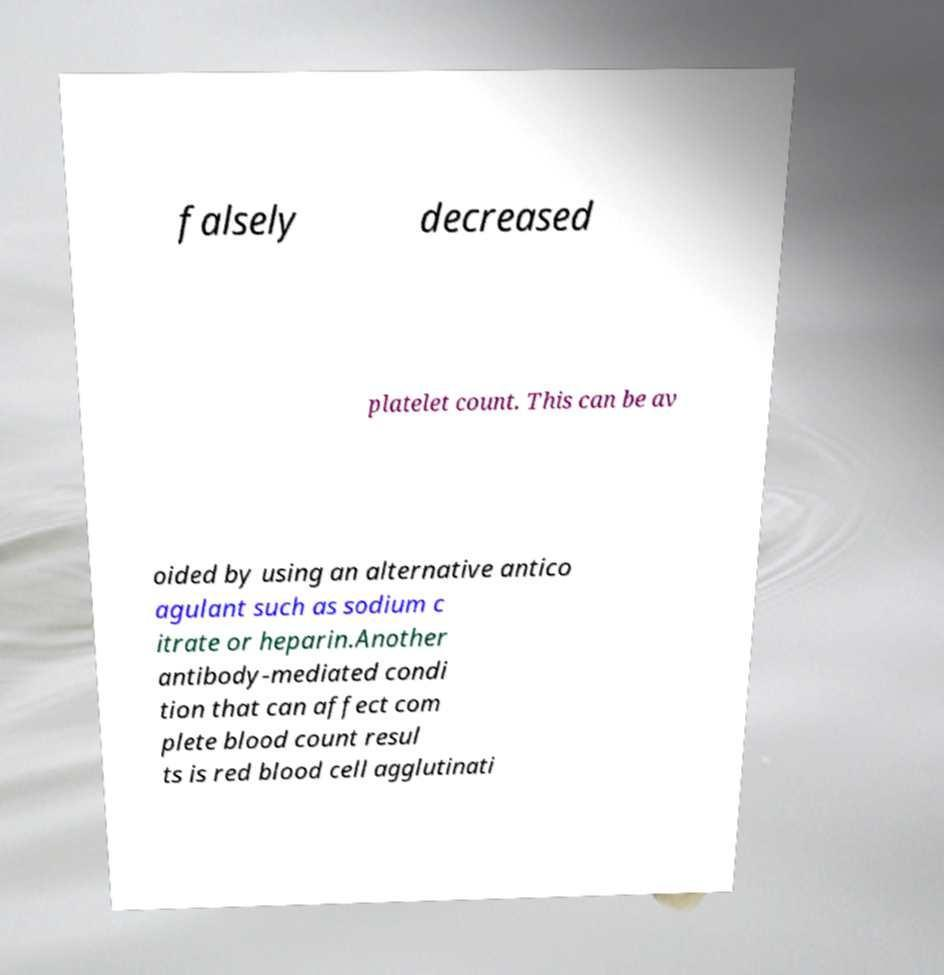Could you assist in decoding the text presented in this image and type it out clearly? falsely decreased platelet count. This can be av oided by using an alternative antico agulant such as sodium c itrate or heparin.Another antibody-mediated condi tion that can affect com plete blood count resul ts is red blood cell agglutinati 